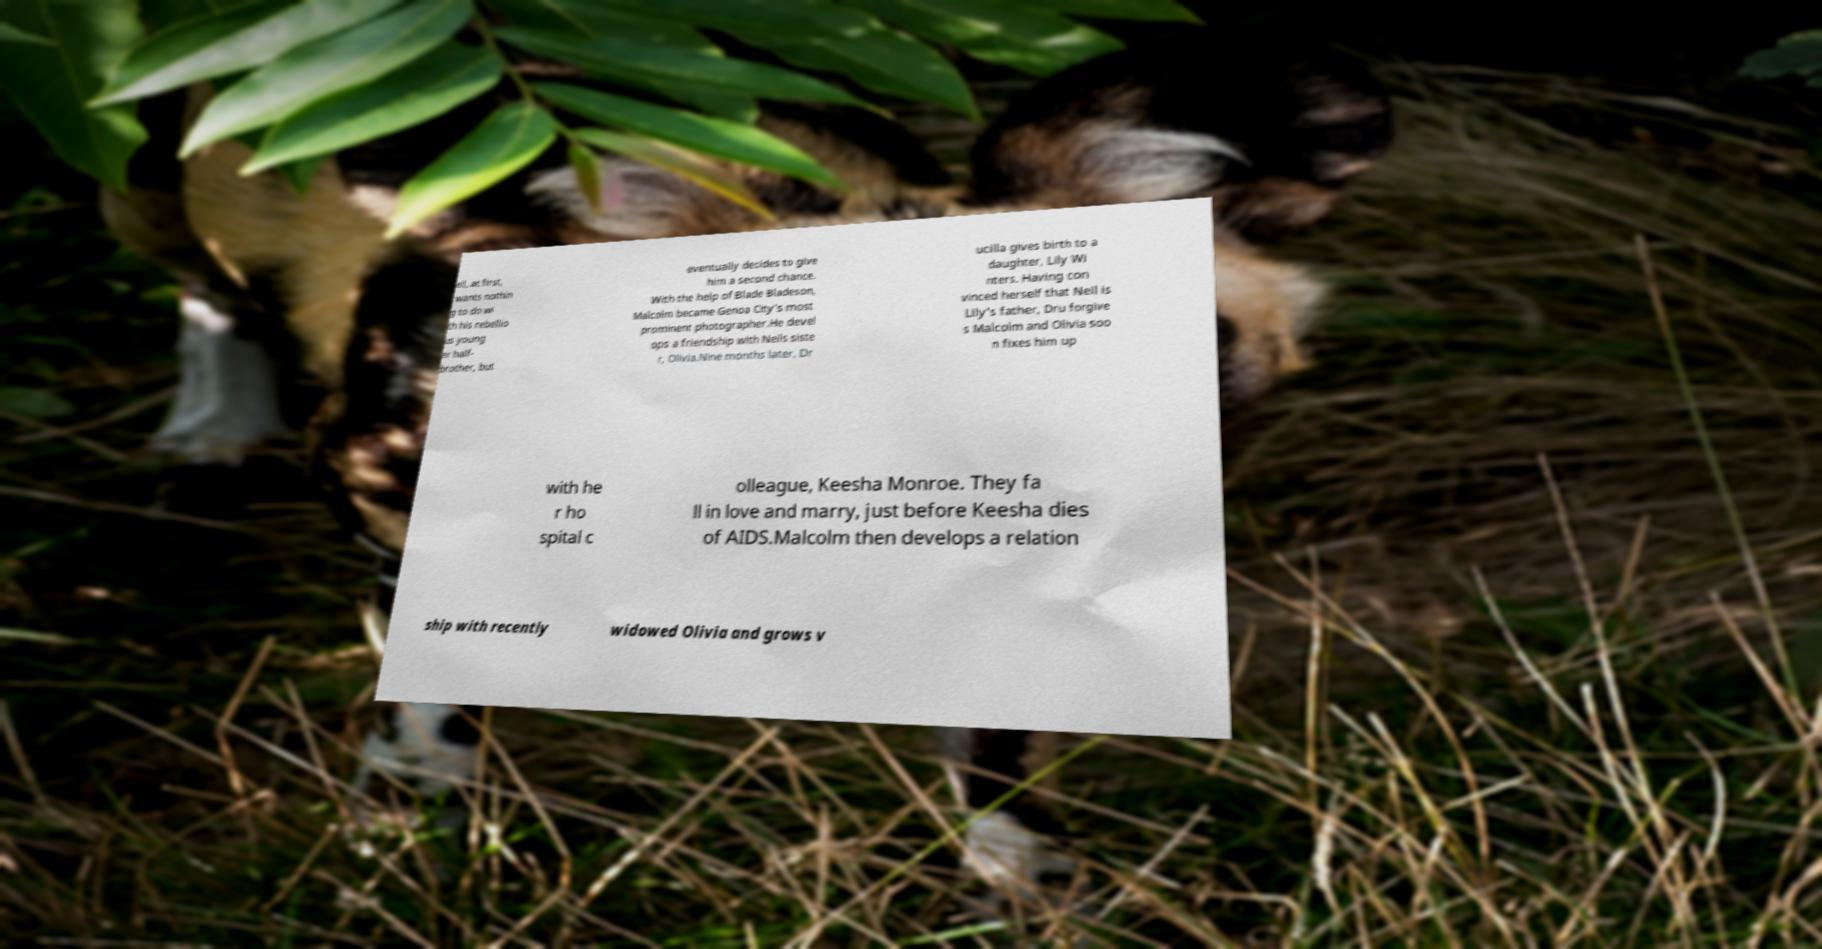Can you accurately transcribe the text from the provided image for me? eil, at first, wants nothin g to do wi th his rebellio us young er half- brother, but eventually decides to give him a second chance. With the help of Blade Bladeson, Malcolm became Genoa City's most prominent photographer.He devel ops a friendship with Neils siste r, Olivia.Nine months later, Dr ucilla gives birth to a daughter, Lily Wi nters. Having con vinced herself that Neil is Lily's father, Dru forgive s Malcolm and Olivia soo n fixes him up with he r ho spital c olleague, Keesha Monroe. They fa ll in love and marry, just before Keesha dies of AIDS.Malcolm then develops a relation ship with recently widowed Olivia and grows v 